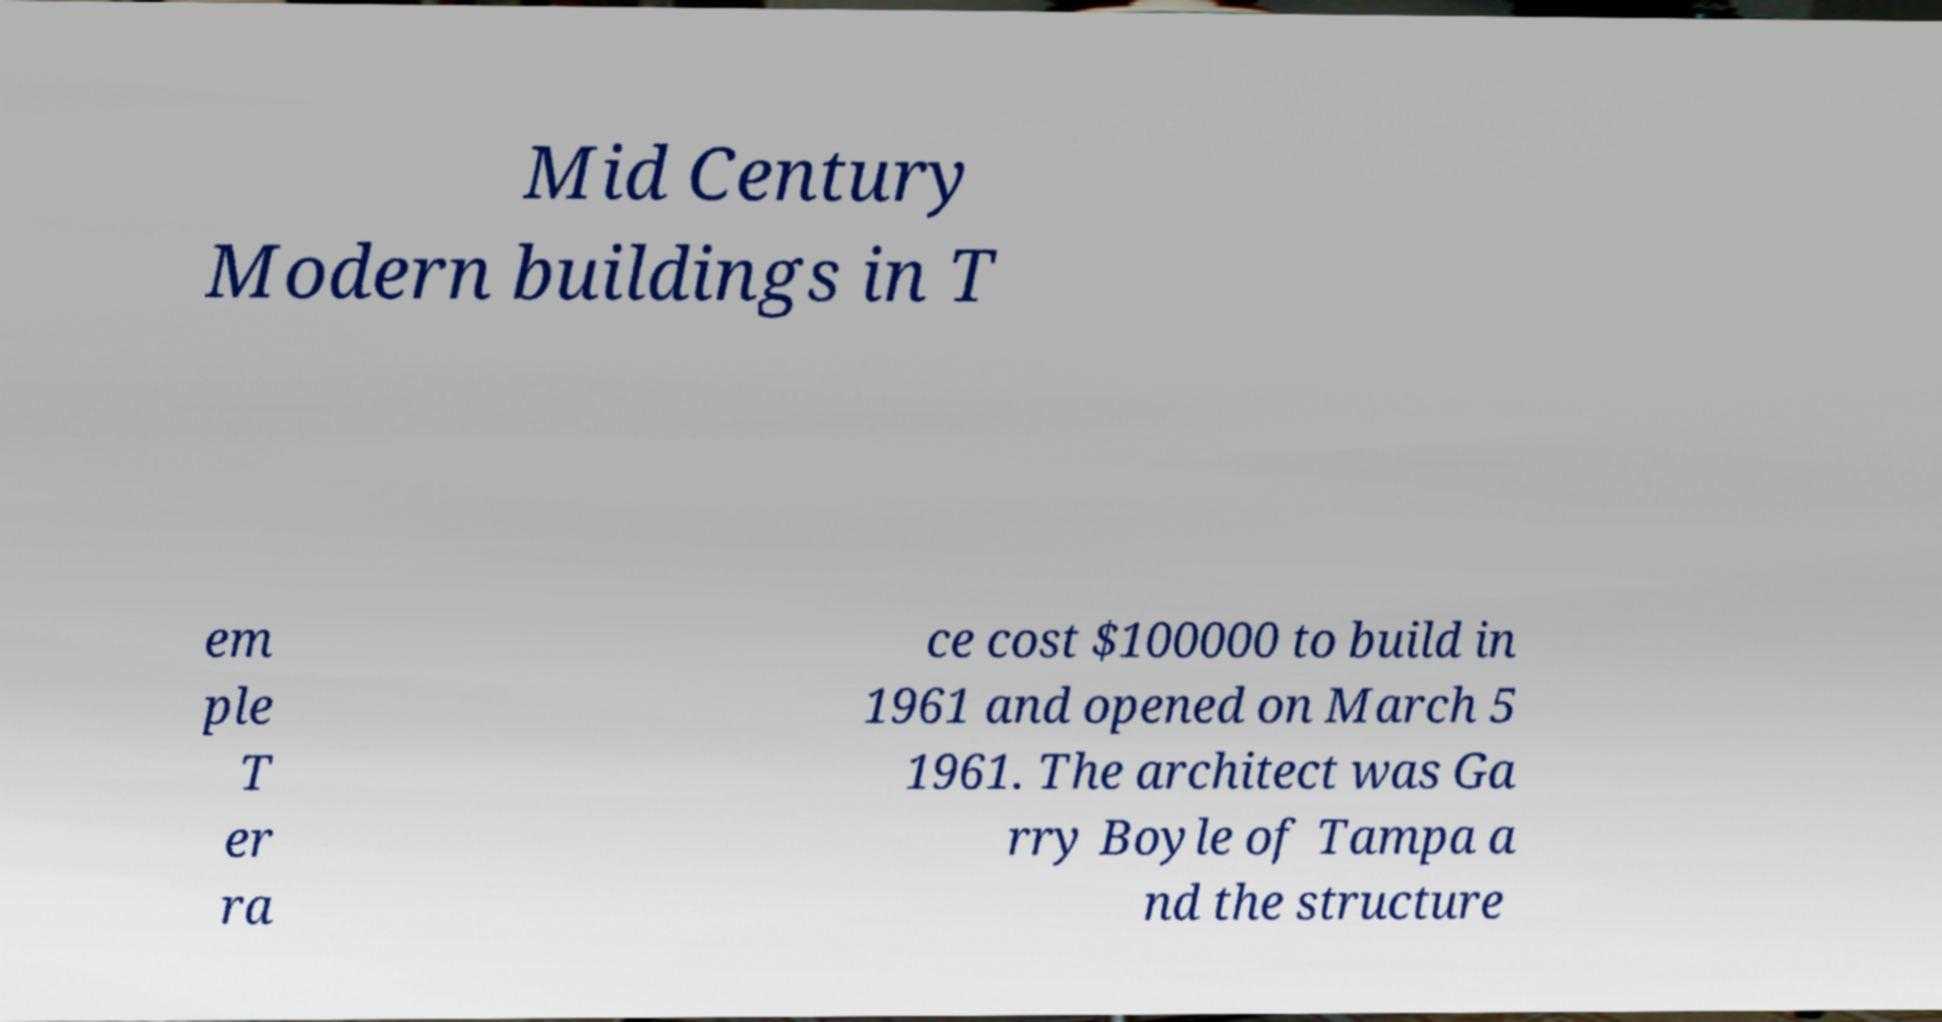What messages or text are displayed in this image? I need them in a readable, typed format. Mid Century Modern buildings in T em ple T er ra ce cost $100000 to build in 1961 and opened on March 5 1961. The architect was Ga rry Boyle of Tampa a nd the structure 